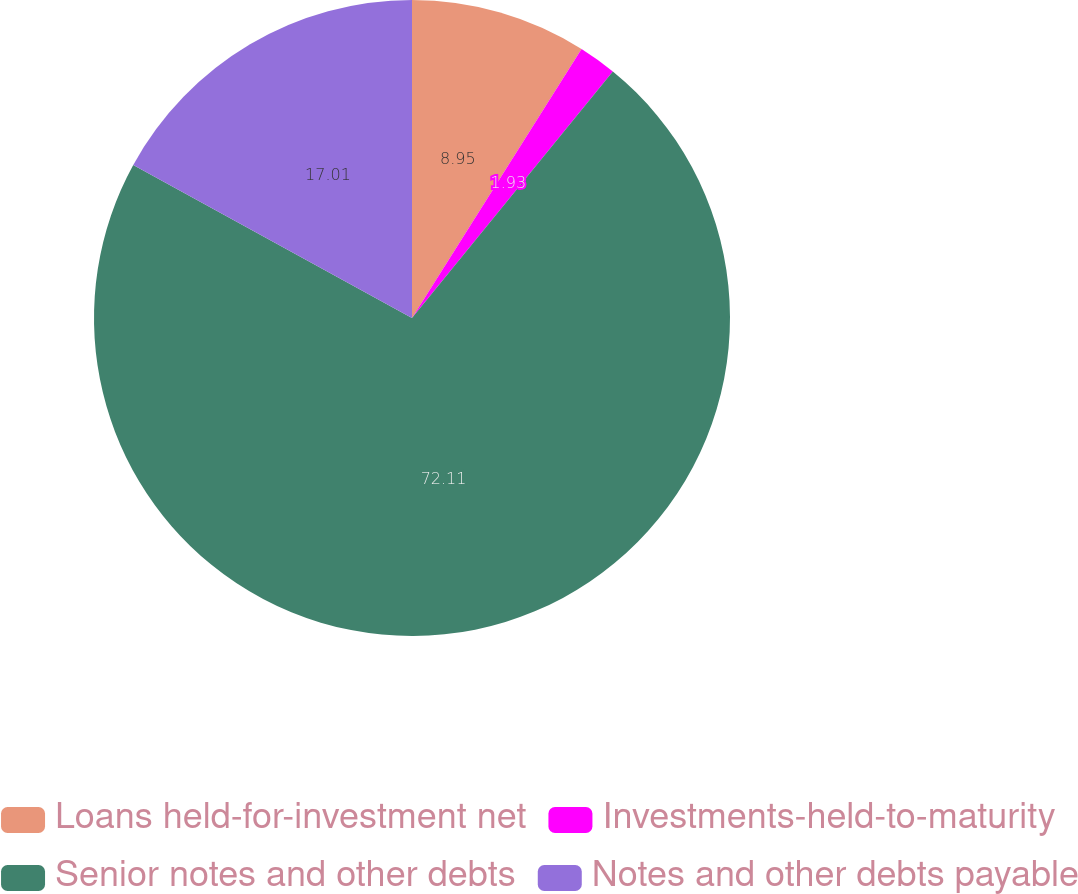Convert chart. <chart><loc_0><loc_0><loc_500><loc_500><pie_chart><fcel>Loans held-for-investment net<fcel>Investments-held-to-maturity<fcel>Senior notes and other debts<fcel>Notes and other debts payable<nl><fcel>8.95%<fcel>1.93%<fcel>72.11%<fcel>17.01%<nl></chart> 